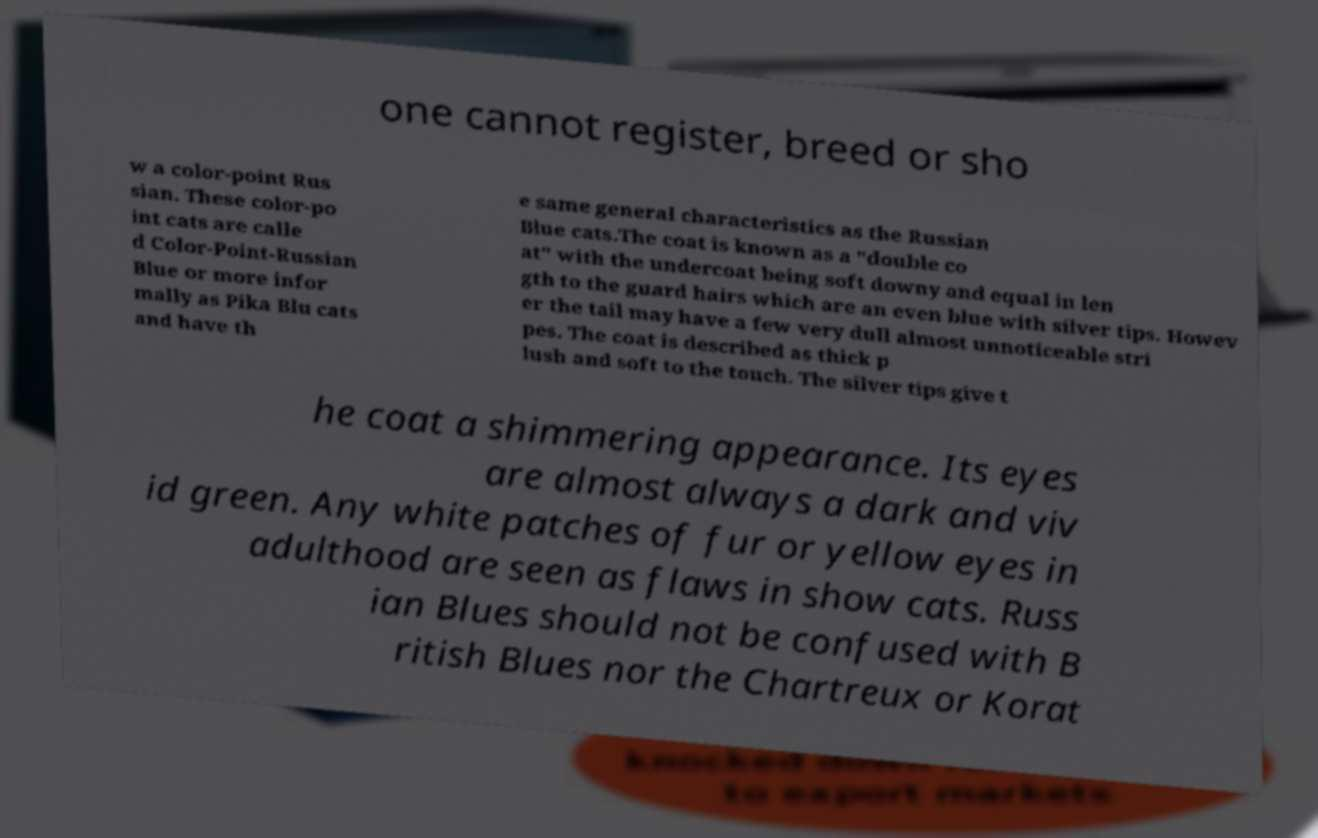Please read and relay the text visible in this image. What does it say? one cannot register, breed or sho w a color-point Rus sian. These color-po int cats are calle d Color-Point-Russian Blue or more infor mally as Pika Blu cats and have th e same general characteristics as the Russian Blue cats.The coat is known as a "double co at" with the undercoat being soft downy and equal in len gth to the guard hairs which are an even blue with silver tips. Howev er the tail may have a few very dull almost unnoticeable stri pes. The coat is described as thick p lush and soft to the touch. The silver tips give t he coat a shimmering appearance. Its eyes are almost always a dark and viv id green. Any white patches of fur or yellow eyes in adulthood are seen as flaws in show cats. Russ ian Blues should not be confused with B ritish Blues nor the Chartreux or Korat 